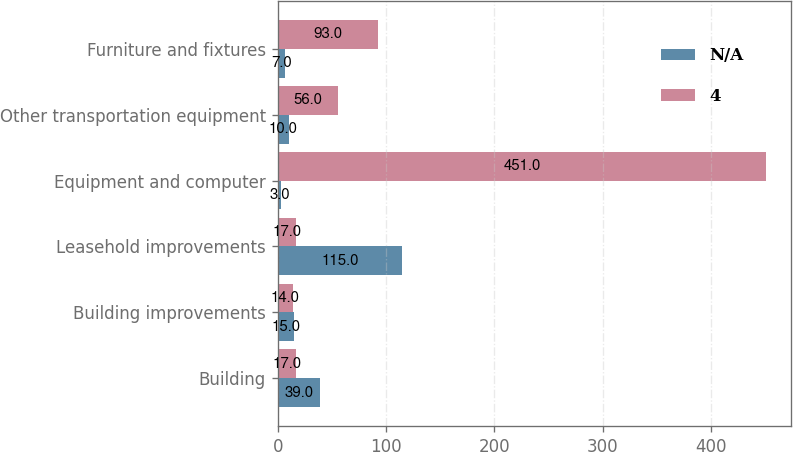Convert chart to OTSL. <chart><loc_0><loc_0><loc_500><loc_500><stacked_bar_chart><ecel><fcel>Building<fcel>Building improvements<fcel>Leasehold improvements<fcel>Equipment and computer<fcel>Other transportation equipment<fcel>Furniture and fixtures<nl><fcel>nan<fcel>39<fcel>15<fcel>115<fcel>3<fcel>10<fcel>7<nl><fcel>4<fcel>17<fcel>14<fcel>17<fcel>451<fcel>56<fcel>93<nl></chart> 